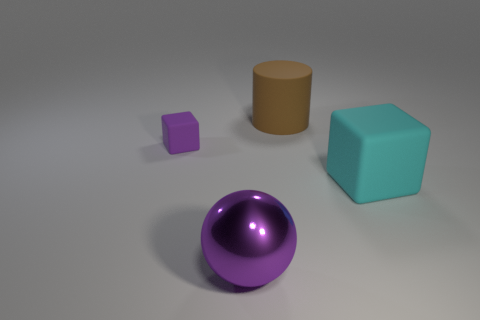What is the size of the rubber object that is the same color as the metallic thing?
Ensure brevity in your answer.  Small. Does the rubber cube that is behind the big cyan rubber object have the same color as the large rubber thing in front of the big brown matte cylinder?
Give a very brief answer. No. What number of things are large spheres or big things?
Give a very brief answer. 3. How many other things are the same shape as the small matte thing?
Provide a succinct answer. 1. Are the purple ball that is in front of the big brown object and the block behind the large cyan thing made of the same material?
Provide a short and direct response. No. There is a object that is to the right of the purple rubber object and to the left of the big brown thing; what is its shape?
Give a very brief answer. Sphere. Are there any other things that are made of the same material as the cyan thing?
Provide a succinct answer. Yes. What is the large thing that is both in front of the matte cylinder and left of the cyan block made of?
Your response must be concise. Metal. The tiny purple thing that is made of the same material as the cyan object is what shape?
Your response must be concise. Cube. Is there anything else of the same color as the matte cylinder?
Your response must be concise. No. 